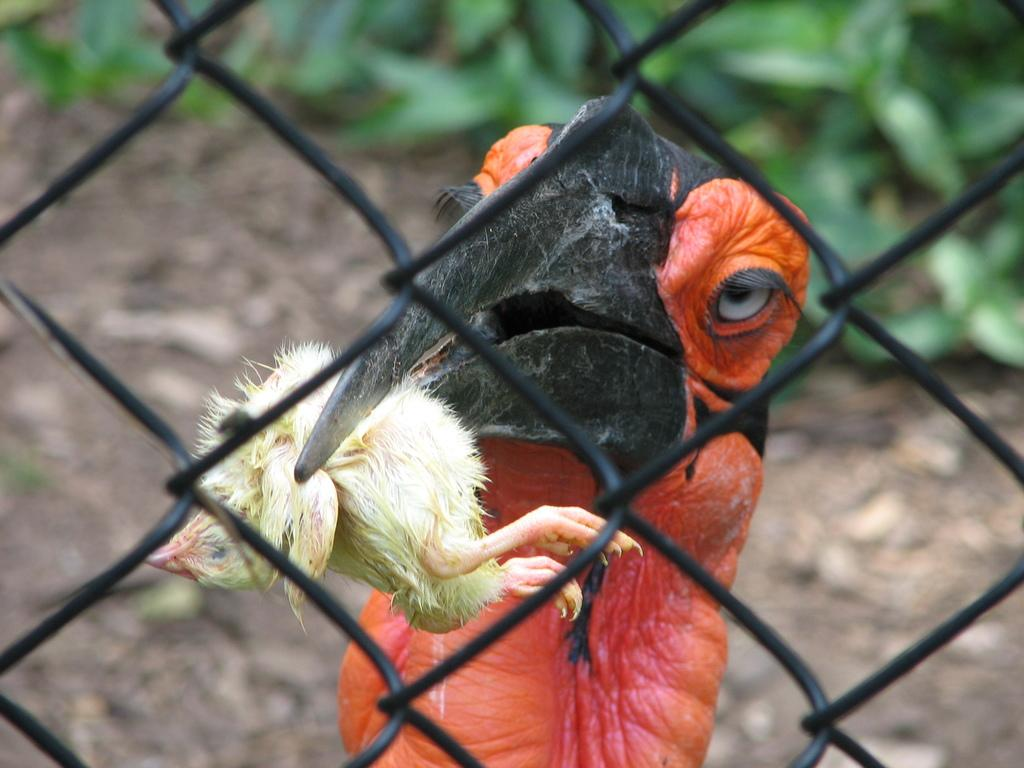What can be seen in the image that resembles a net or grid? There is a mesh in the image. What activity is the bird engaged in? The bird is holding a baby bird on its beak. What can be seen in the distance in the image? The sky is visible in the background of the image. What type of suit is the bird wearing in the image? There is no suit present in the image; the bird is a wild animal and does not wear clothing. Where is the school located in the image? There is no school present in the image; the focus is on the bird and its baby bird. 